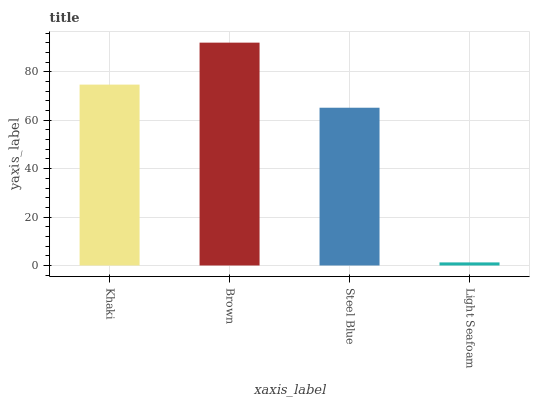Is Light Seafoam the minimum?
Answer yes or no. Yes. Is Brown the maximum?
Answer yes or no. Yes. Is Steel Blue the minimum?
Answer yes or no. No. Is Steel Blue the maximum?
Answer yes or no. No. Is Brown greater than Steel Blue?
Answer yes or no. Yes. Is Steel Blue less than Brown?
Answer yes or no. Yes. Is Steel Blue greater than Brown?
Answer yes or no. No. Is Brown less than Steel Blue?
Answer yes or no. No. Is Khaki the high median?
Answer yes or no. Yes. Is Steel Blue the low median?
Answer yes or no. Yes. Is Light Seafoam the high median?
Answer yes or no. No. Is Light Seafoam the low median?
Answer yes or no. No. 